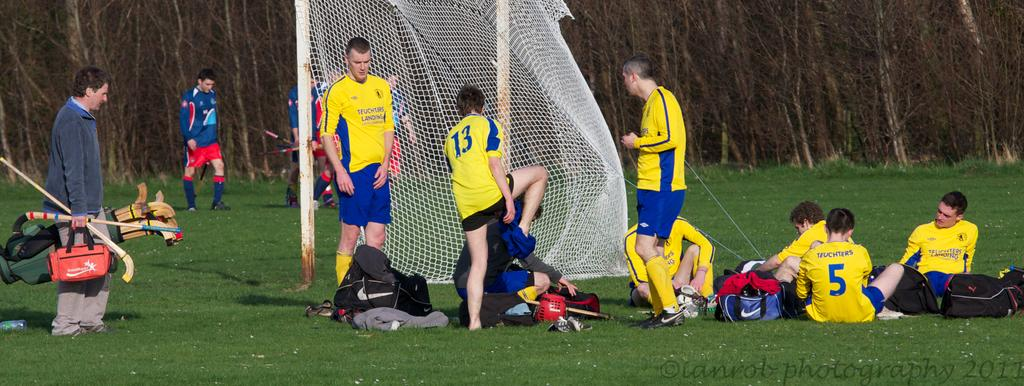<image>
Relay a brief, clear account of the picture shown. A boy is taking his pants off, he has the number thirteen on his jersey. 